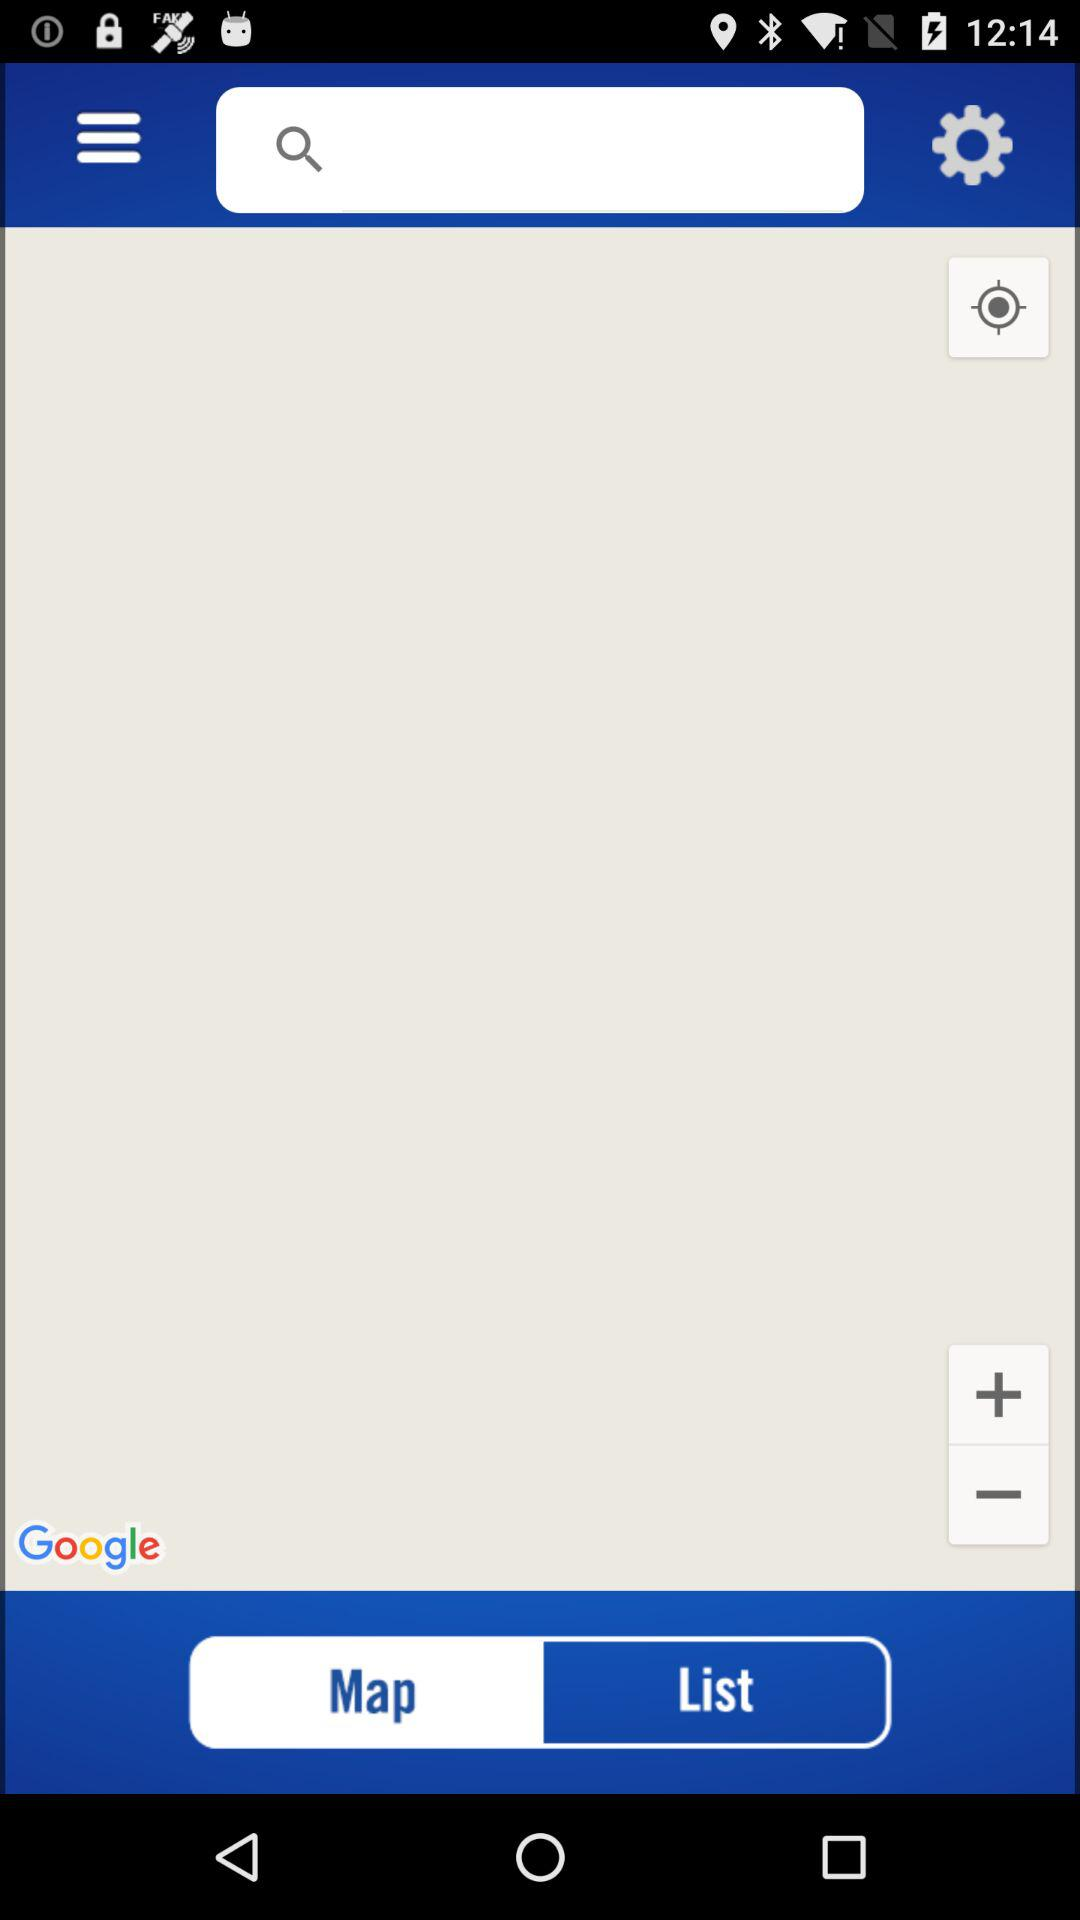Which tab is currently selected? The tab "Map" is currently selected. 